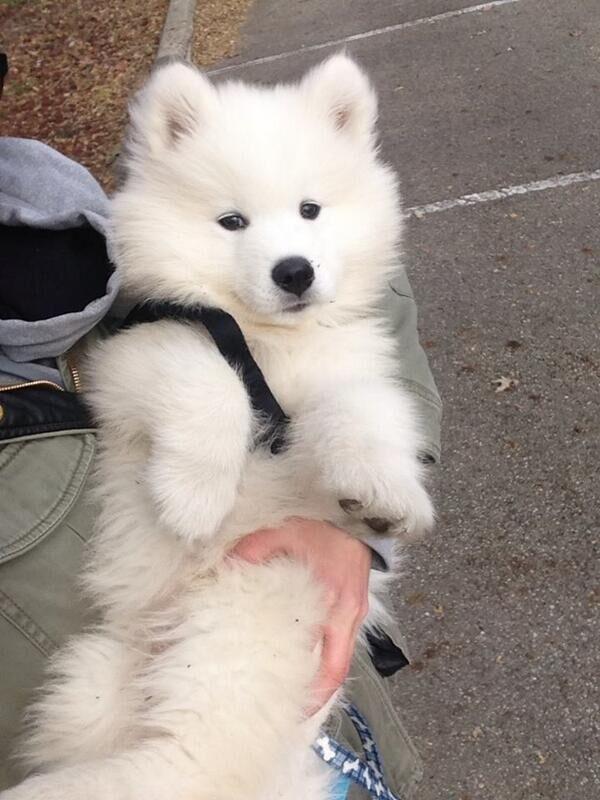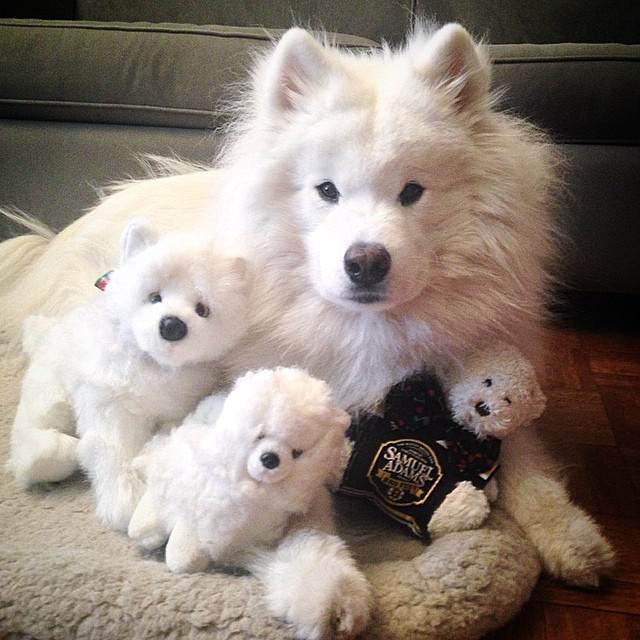The first image is the image on the left, the second image is the image on the right. Evaluate the accuracy of this statement regarding the images: "there is grass visible behind a white dog.". Is it true? Answer yes or no. No. The first image is the image on the left, the second image is the image on the right. For the images shown, is this caption "One image contains multiple white dog figures, and the other image shows one white dog held up by a human arm." true? Answer yes or no. Yes. 